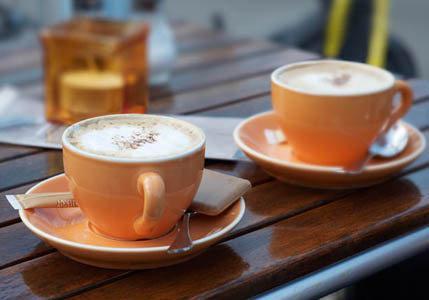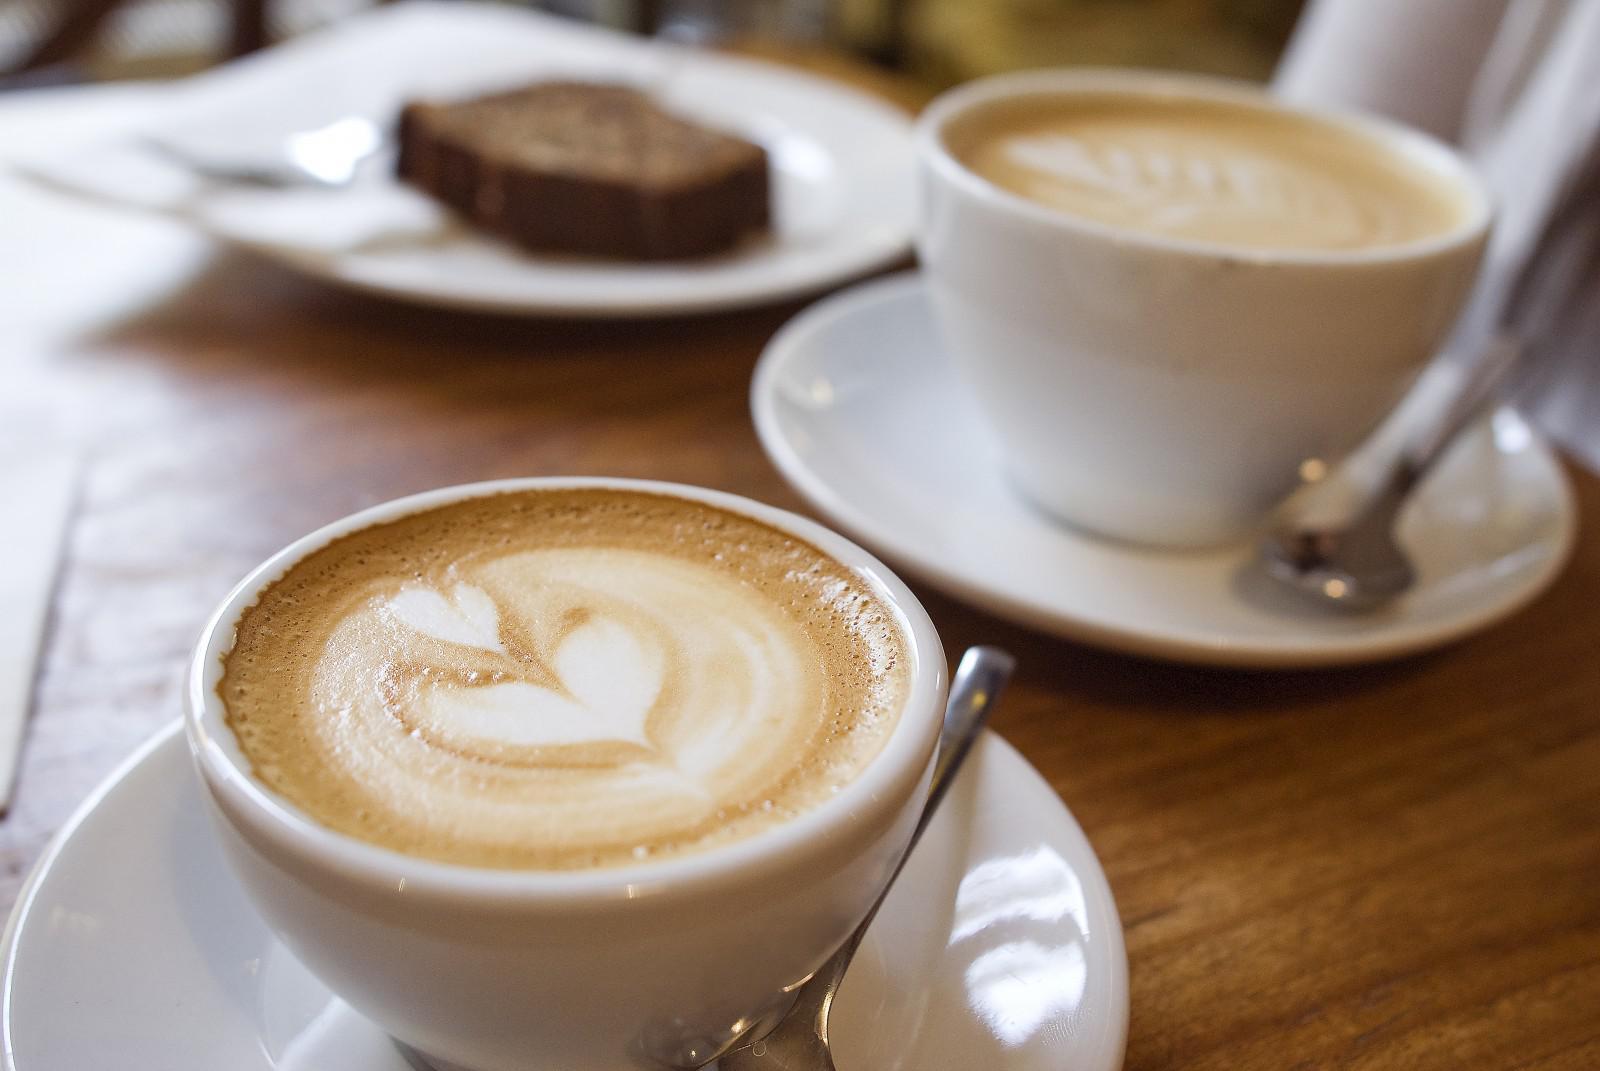The first image is the image on the left, the second image is the image on the right. Assess this claim about the two images: "A pair of white cups sit on a folded woven beige cloth with a scattering of coffee beans on it.". Correct or not? Answer yes or no. No. 